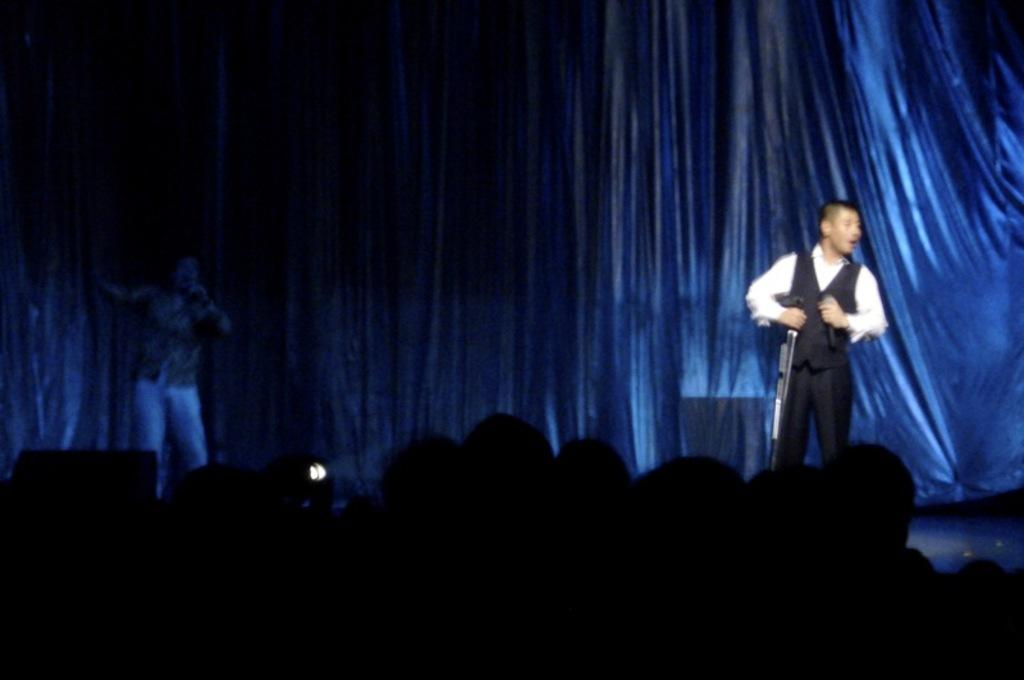What is happening on the dais in the image? There are humans performing on a dais in the image. Can you describe the lighting in the image? There is light visible in the image. What can be seen in the background of the image? There is a curtain in the background of the image. Who is present at the bottom of the image? There is an audience at the bottom of the image. What type of nut is being used as a prop by the performers in the image? There is no nut present in the image; the performers are not using any props related to nuts. 